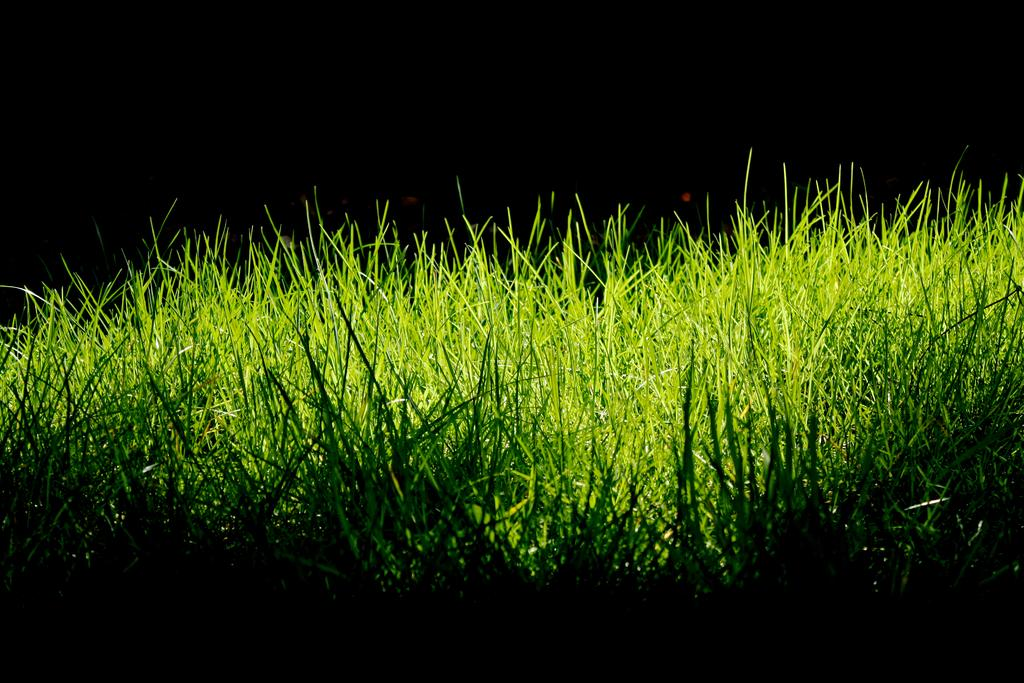What type of vegetation is visible in the image? There is grass in the image. What type of lettuce can be seen growing in the image? There is no lettuce present in the image; it only features grass. Can you see a dog playing with a tooth in the image? There is no dog or tooth present in the image. 